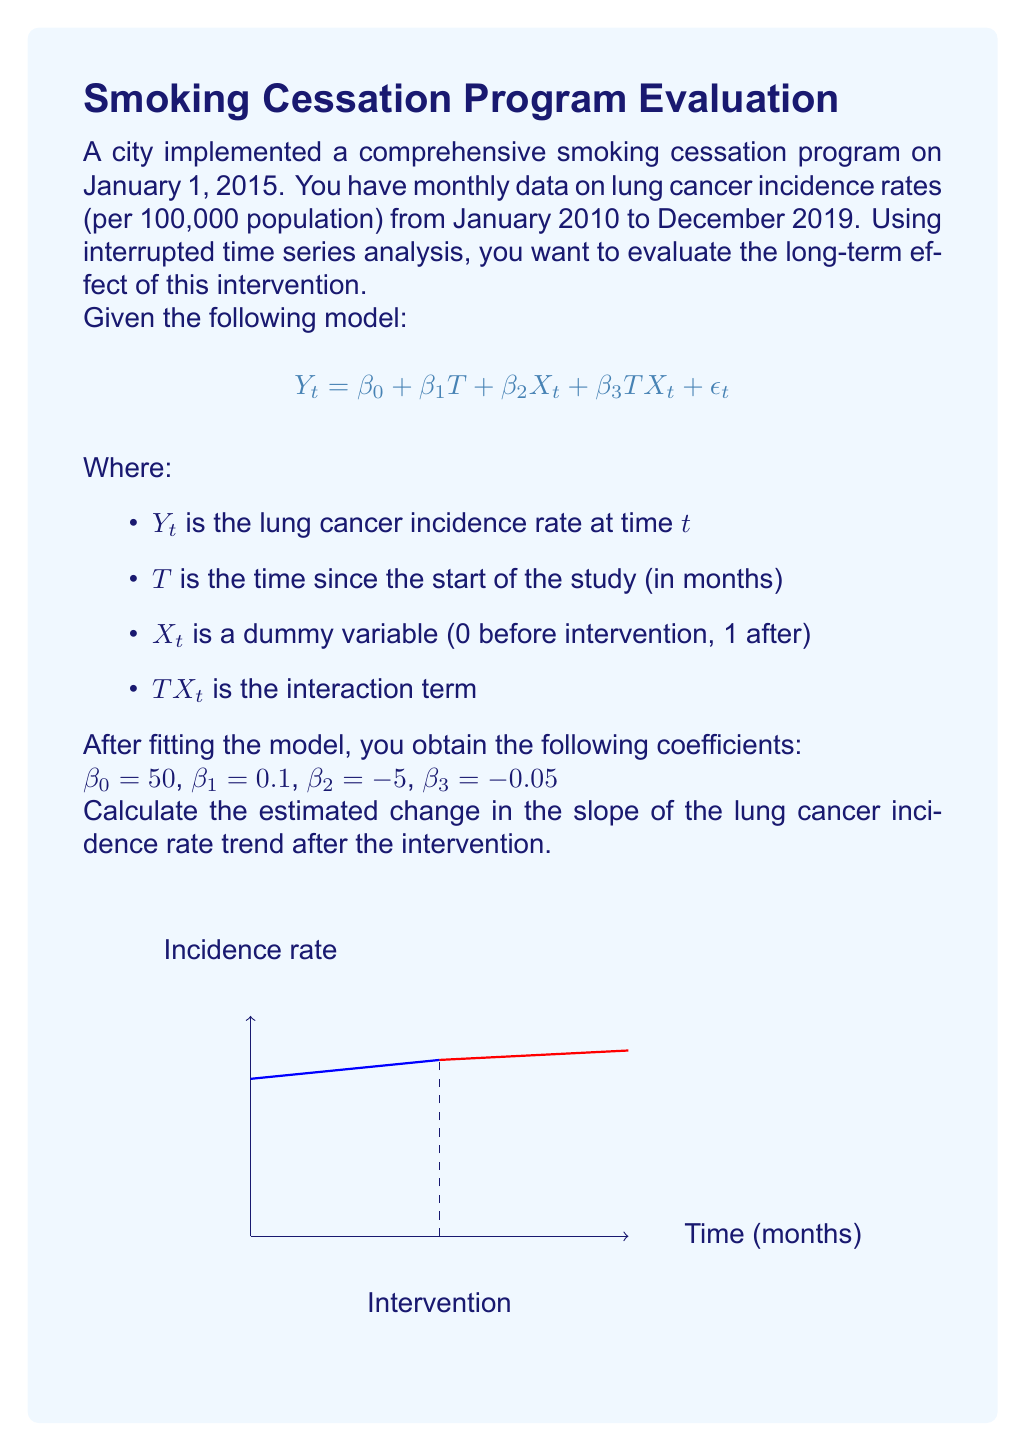Can you answer this question? To solve this problem, we need to understand the components of the interrupted time series model:

1) $\beta_0$ is the baseline level at T=0
2) $\beta_1$ is the slope before the intervention
3) $\beta_2$ is the change in level immediately after the intervention
4) $\beta_3$ is the change in slope after the intervention

The slope before the intervention is represented by $\beta_1 = 0.1$.

The slope after the intervention is represented by $\beta_1 + \beta_3 = 0.1 + (-0.05) = 0.05$.

To calculate the change in slope, we subtract the slope before the intervention from the slope after the intervention:

$\text{Change in slope} = (\beta_1 + \beta_3) - \beta_1 = \beta_3$

Therefore, the change in slope is equal to $\beta_3 = -0.05$.

This means that after the intervention, the slope of the lung cancer incidence rate trend decreased by 0.05 units per month compared to the pre-intervention trend.
Answer: $-0.05$ units per month 